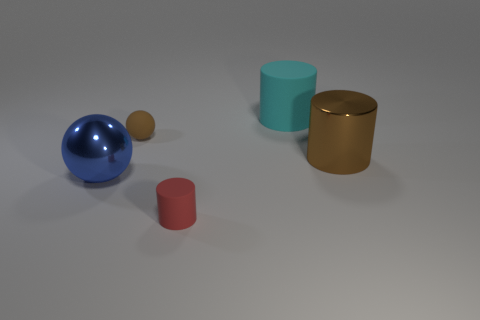Subtract all rubber cylinders. How many cylinders are left? 1 Add 3 large cyan matte things. How many objects exist? 8 Subtract 1 cylinders. How many cylinders are left? 2 Subtract all spheres. How many objects are left? 3 Add 4 big cylinders. How many big cylinders exist? 6 Subtract 0 red balls. How many objects are left? 5 Subtract all big cylinders. Subtract all big cyan rubber cylinders. How many objects are left? 2 Add 1 large shiny spheres. How many large shiny spheres are left? 2 